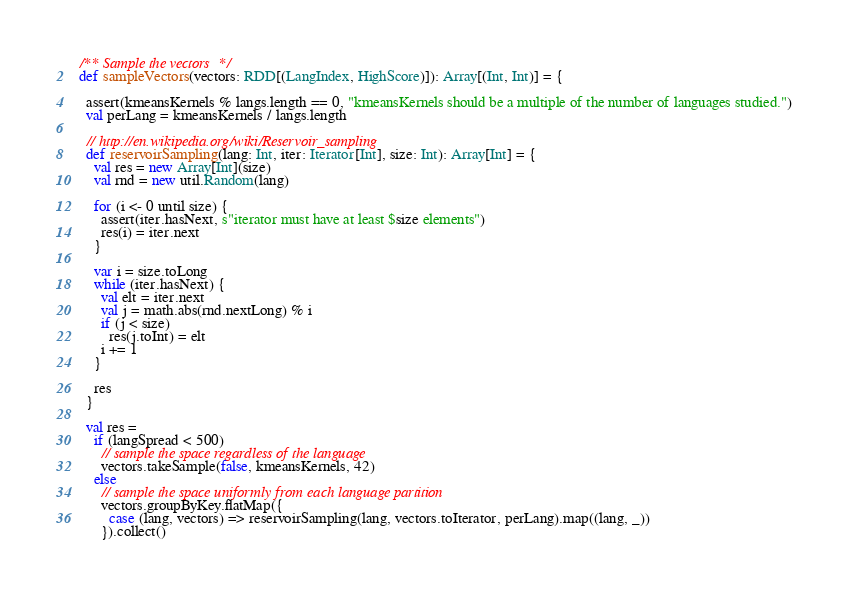Convert code to text. <code><loc_0><loc_0><loc_500><loc_500><_Scala_>  /** Sample the vectors */
  def sampleVectors(vectors: RDD[(LangIndex, HighScore)]): Array[(Int, Int)] = {

    assert(kmeansKernels % langs.length == 0, "kmeansKernels should be a multiple of the number of languages studied.")
    val perLang = kmeansKernels / langs.length

    // http://en.wikipedia.org/wiki/Reservoir_sampling
    def reservoirSampling(lang: Int, iter: Iterator[Int], size: Int): Array[Int] = {
      val res = new Array[Int](size)
      val rnd = new util.Random(lang)

      for (i <- 0 until size) {
        assert(iter.hasNext, s"iterator must have at least $size elements")
        res(i) = iter.next
      }

      var i = size.toLong
      while (iter.hasNext) {
        val elt = iter.next
        val j = math.abs(rnd.nextLong) % i
        if (j < size)
          res(j.toInt) = elt
        i += 1
      }

      res
    }

    val res =
      if (langSpread < 500)
        // sample the space regardless of the language
        vectors.takeSample(false, kmeansKernels, 42)
      else
        // sample the space uniformly from each language partition
        vectors.groupByKey.flatMap({
          case (lang, vectors) => reservoirSampling(lang, vectors.toIterator, perLang).map((lang, _))
        }).collect()
</code> 